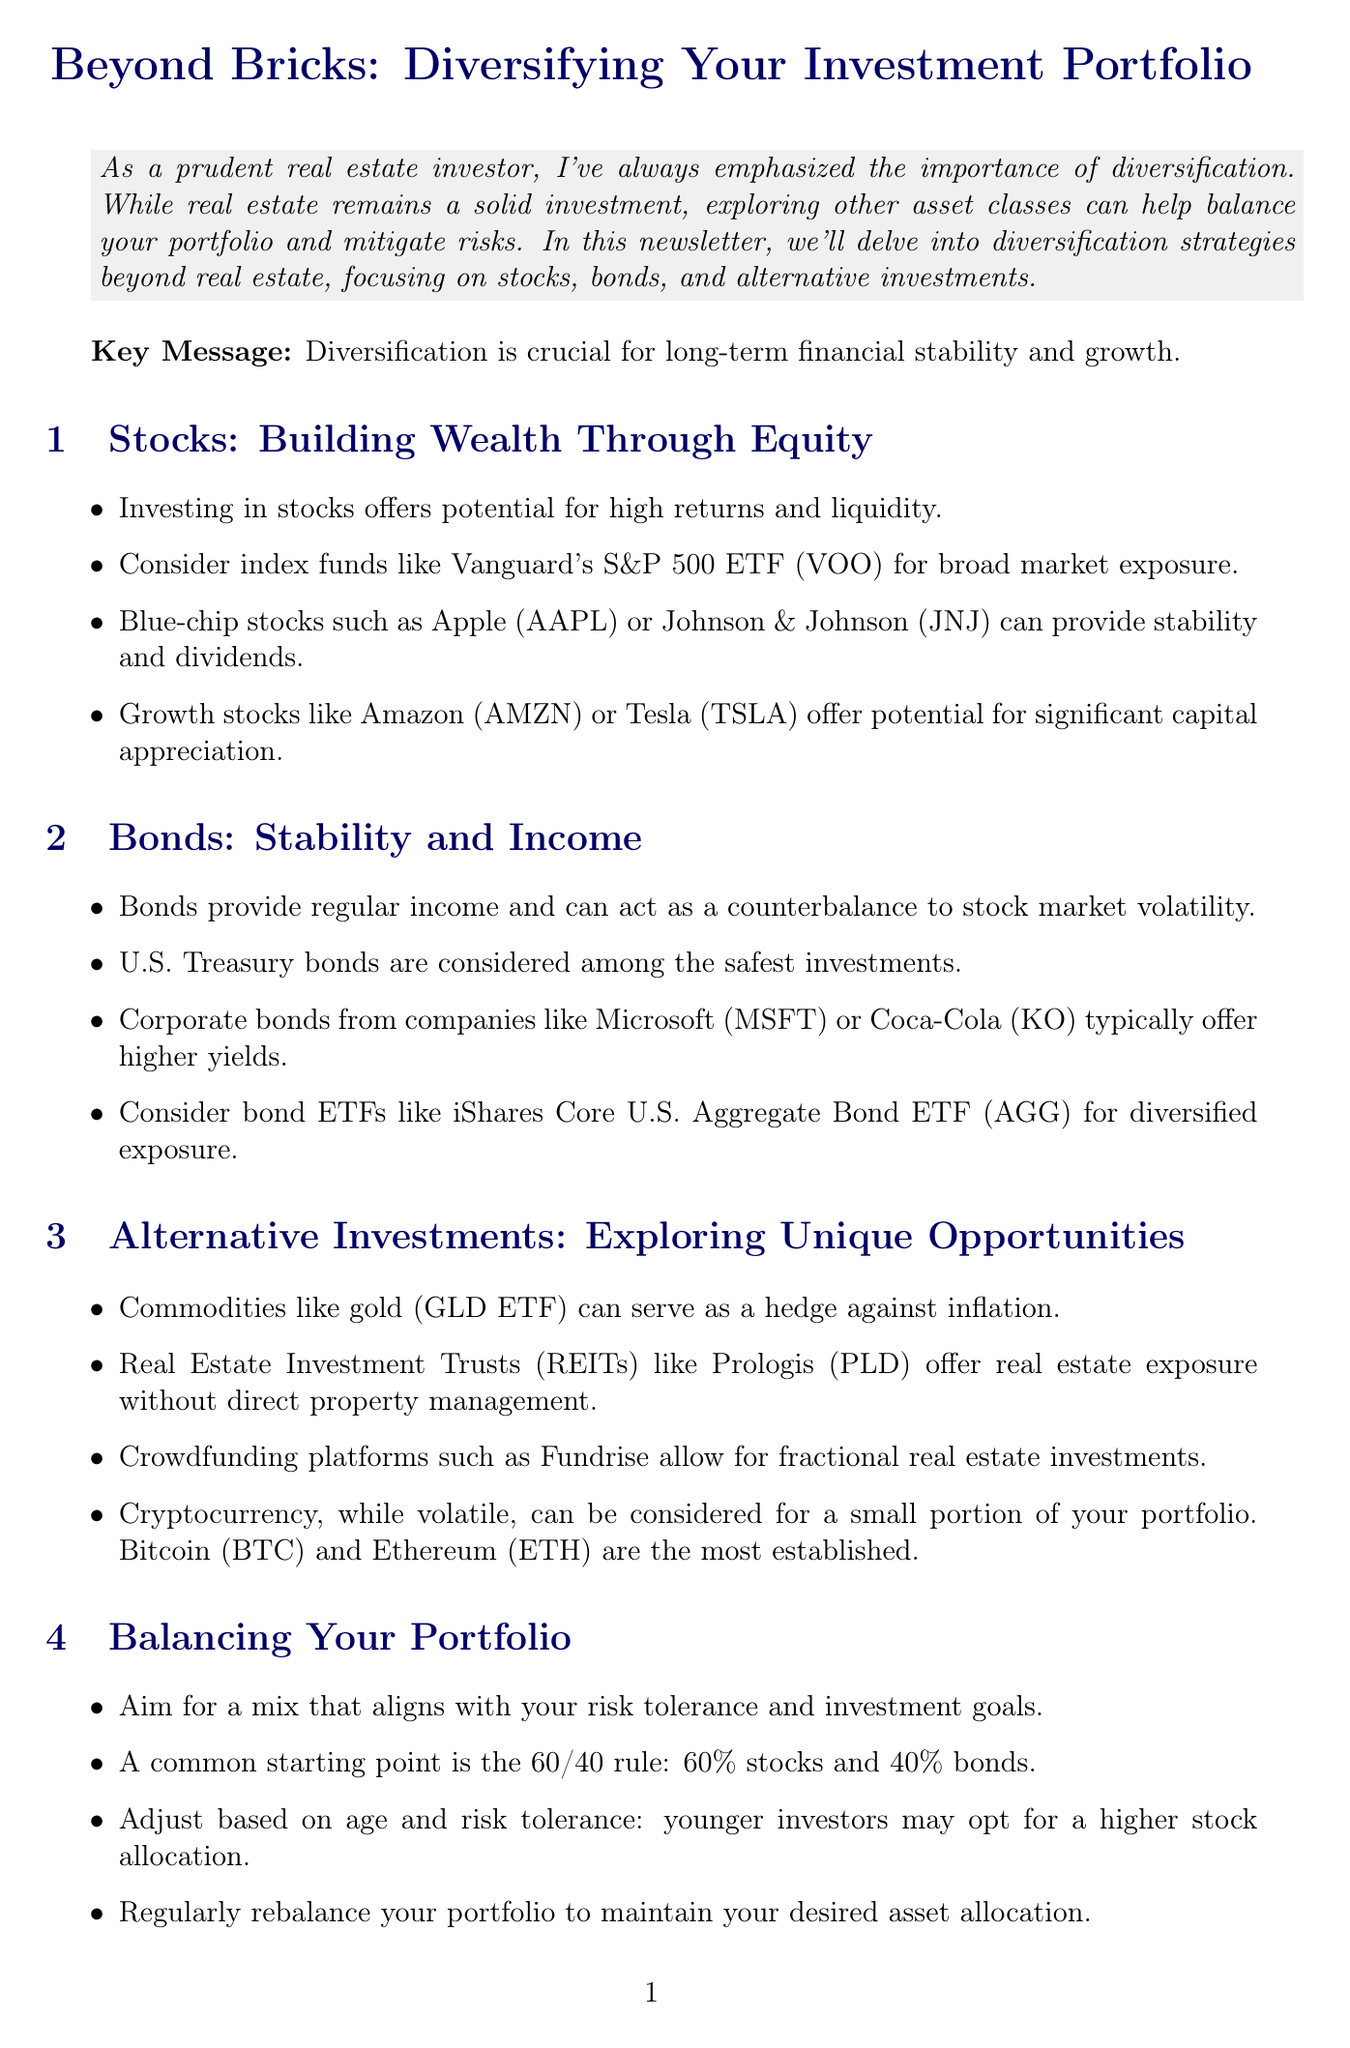What is the newsletter title? The title represents the main focus of the document, which is about diversifying investment portfolios.
Answer: Beyond Bricks: Diversifying Your Investment Portfolio What is a recommended stock investment for broad market exposure? This item highlights a specific investment option for stocks that covers a wide range of companies.
Answer: Vanguard's S&P 500 ETF (VOO) What percentage of Sarah's portfolio is allocated to stocks? This question asks for a specific numerical allocation from the case study about Sarah's investment strategy.
Answer: 30% Which bond ETF is suggested for diversified exposure? This item identifies a specific bond ETF mentioned as a suitable investment option.
Answer: iShares Core U.S. Aggregate Bond ETF (AGG) What is the common starting point for portfolio allocation mentioned in the document? This question looks for a specific rule regarding how to split investments between stocks and bonds.
Answer: 60/40 rule What alternative investment is mentioned that serves as a hedge against inflation? This item points to a specific type of investment that protects against inflation, as described in the alternatives section.
Answer: Gold (GLD ETF) What is the key message emphasized in the introduction? This question asks for the main takeaway or theme that the document suggests regarding investments and risk.
Answer: Diversification is crucial for long-term financial stability and growth What type of investor is the case study about? This question identifies the main character's occupation and investment strategy in the case study.
Answer: Real estate investor 